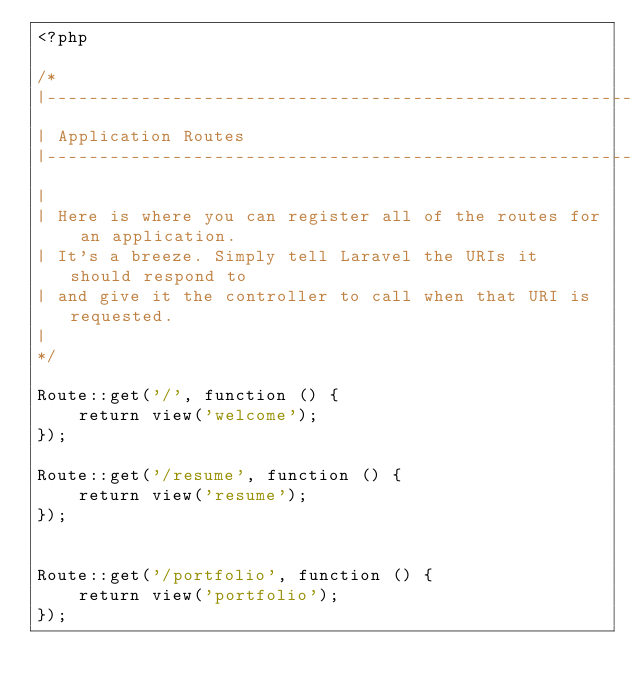<code> <loc_0><loc_0><loc_500><loc_500><_PHP_><?php

/*
|--------------------------------------------------------------------------
| Application Routes
|--------------------------------------------------------------------------
|
| Here is where you can register all of the routes for an application.
| It's a breeze. Simply tell Laravel the URIs it should respond to
| and give it the controller to call when that URI is requested.
|
*/

Route::get('/', function () {
    return view('welcome');
});

Route::get('/resume', function () {
    return view('resume');
});


Route::get('/portfolio', function () {
    return view('portfolio');
});

</code> 